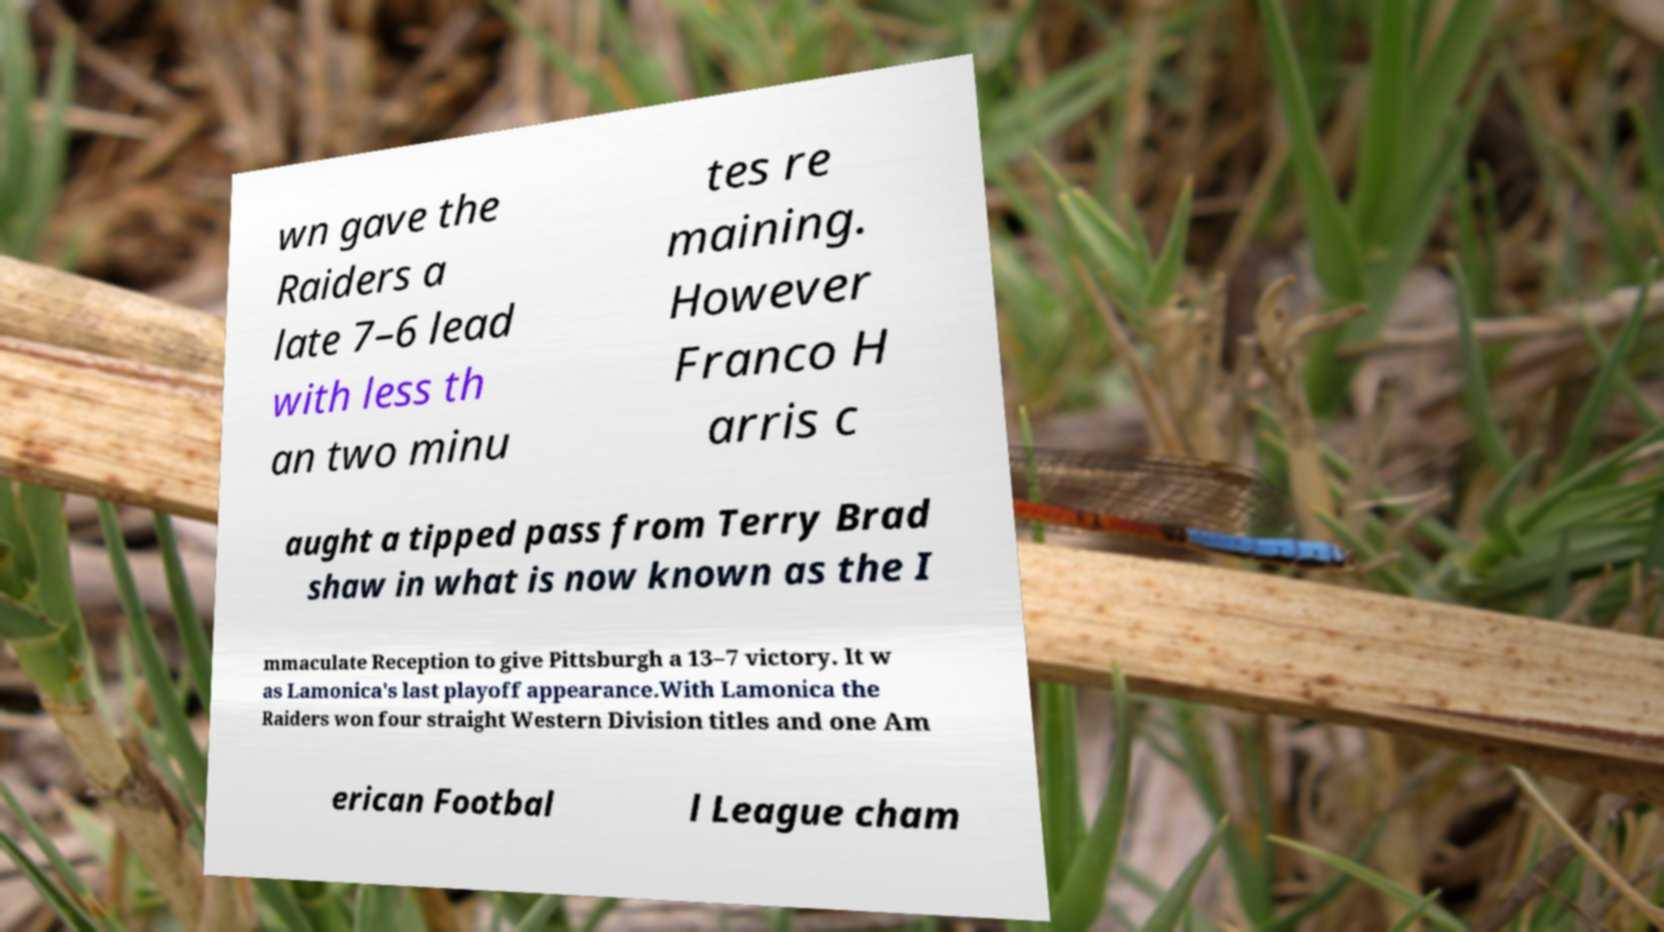What messages or text are displayed in this image? I need them in a readable, typed format. wn gave the Raiders a late 7–6 lead with less th an two minu tes re maining. However Franco H arris c aught a tipped pass from Terry Brad shaw in what is now known as the I mmaculate Reception to give Pittsburgh a 13–7 victory. It w as Lamonica's last playoff appearance.With Lamonica the Raiders won four straight Western Division titles and one Am erican Footbal l League cham 